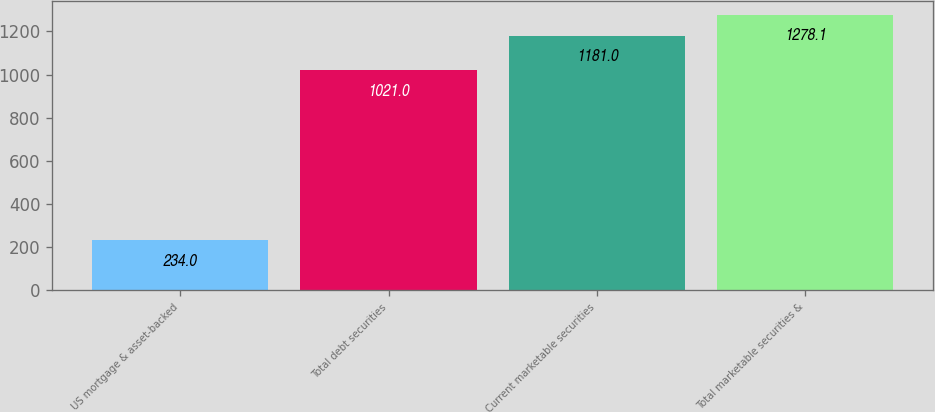Convert chart. <chart><loc_0><loc_0><loc_500><loc_500><bar_chart><fcel>US mortgage & asset-backed<fcel>Total debt securities<fcel>Current marketable securities<fcel>Total marketable securities &<nl><fcel>234<fcel>1021<fcel>1181<fcel>1278.1<nl></chart> 